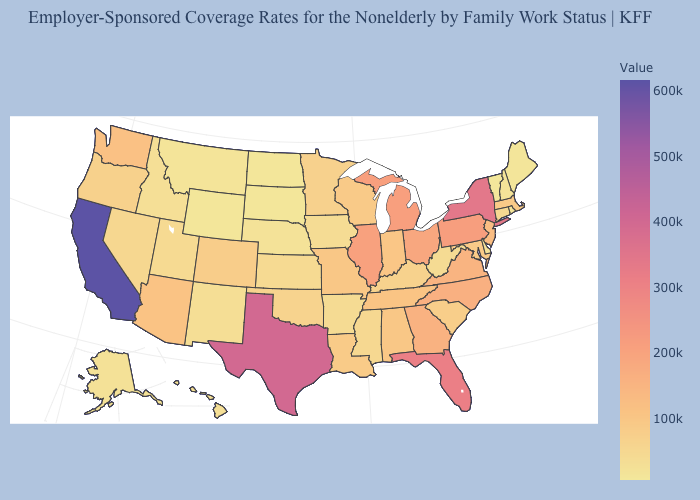Does Nevada have the highest value in the West?
Be succinct. No. Does the map have missing data?
Concise answer only. No. Does the map have missing data?
Write a very short answer. No. 